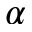Convert formula to latex. <formula><loc_0><loc_0><loc_500><loc_500>\alpha</formula> 